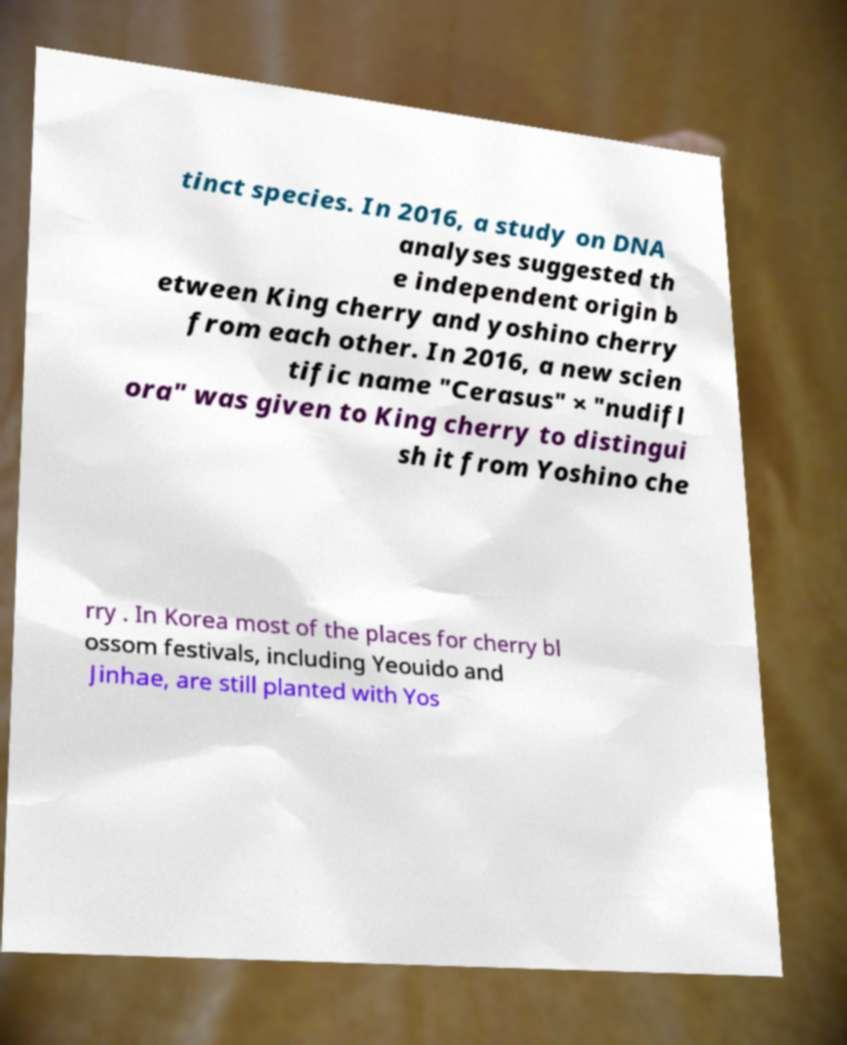What messages or text are displayed in this image? I need them in a readable, typed format. tinct species. In 2016, a study on DNA analyses suggested th e independent origin b etween King cherry and yoshino cherry from each other. In 2016, a new scien tific name "Cerasus" × "nudifl ora" was given to King cherry to distingui sh it from Yoshino che rry . In Korea most of the places for cherry bl ossom festivals, including Yeouido and Jinhae, are still planted with Yos 